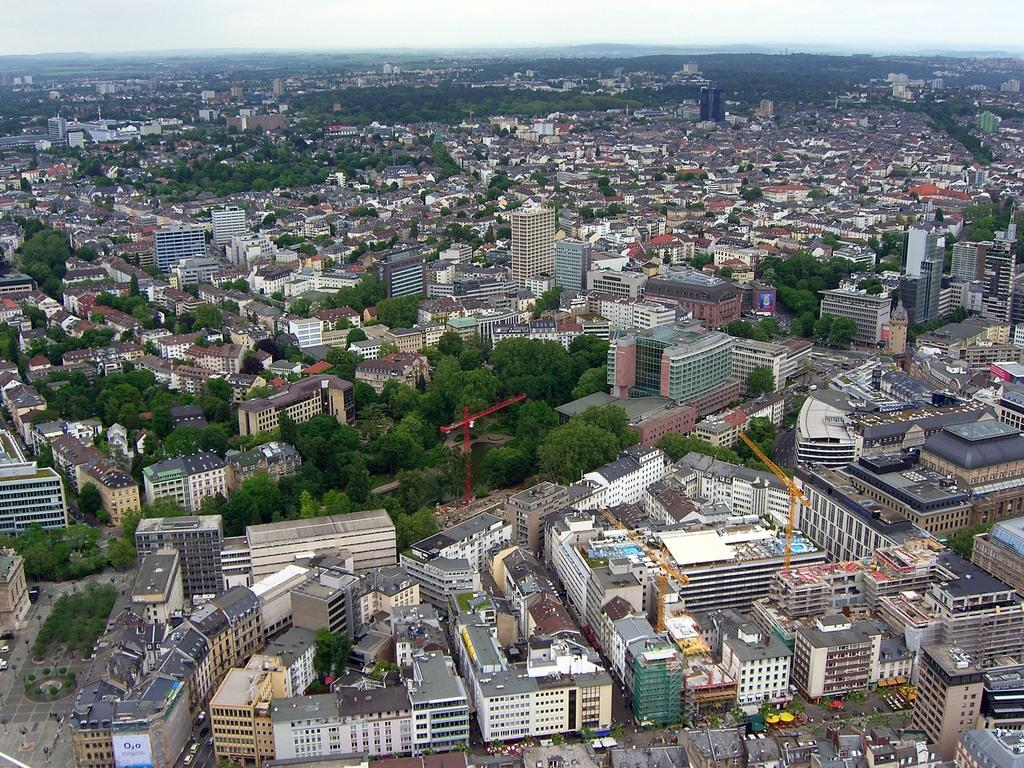What type of view is shown in the image? The image is an aerial view. What structures can be seen in the image? There are buildings, trees, poles, and towers in the image. What is moving on the roads in the image? There are vehicles on the roads in the image. What type of stove is visible in the image? There is no stove present in the image. Can you tell me how the order of the buildings is arranged in the image? The order of the buildings cannot be determined from the image alone, as it only provides an aerial view without any specific arrangement details. 